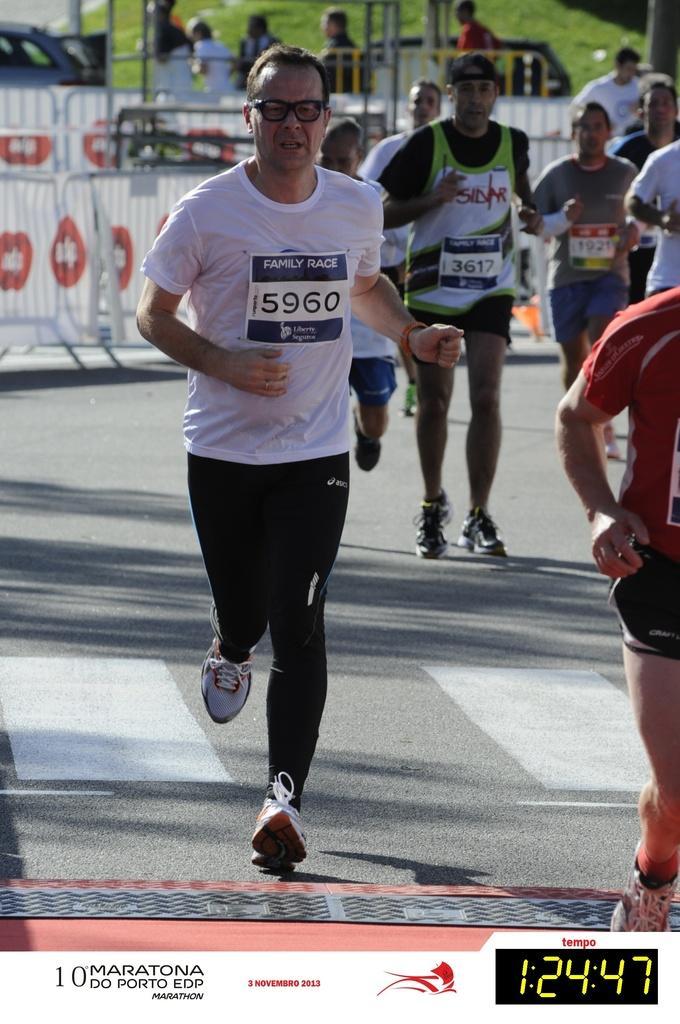Can you describe this image briefly? In this image there are a group of people who are running, and at the bottom there is a road. And at the bottom of the image there is some text, and in the background there is a railing, poles, grass and some people and vehicles. 